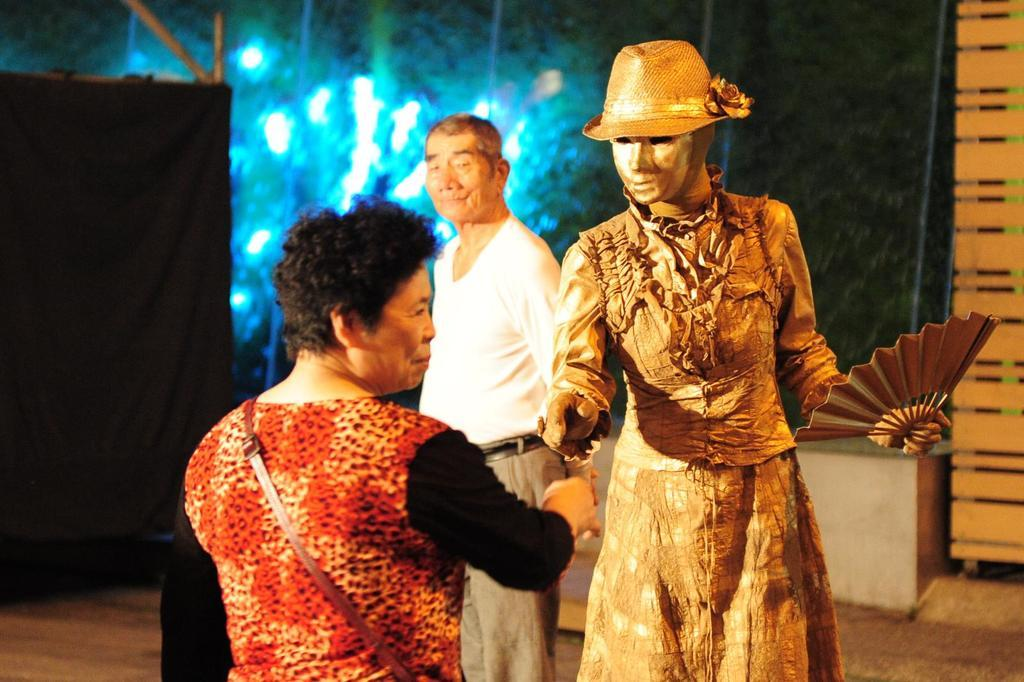How many people are present in the image? There are three persons standing in the image. What can be seen in the background of the image? There is a wall visible in the background of the image. What type of ticket is the person holding in the image? There is no ticket present in the image; it only shows three persons standing and a wall in the background. 